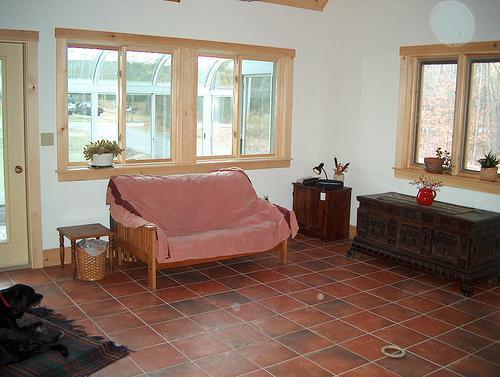How many sofas are pictured?
Give a very brief answer. 1. 